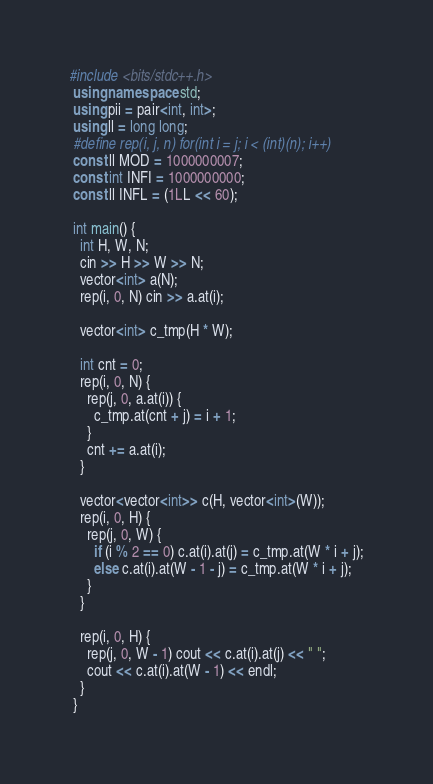<code> <loc_0><loc_0><loc_500><loc_500><_C++_>#include <bits/stdc++.h>
 using namespace std;
 using pii = pair<int, int>;
 using ll = long long;
 #define rep(i, j, n) for(int i = j; i < (int)(n); i++)
 const ll MOD = 1000000007;
 const int INFI = 1000000000;
 const ll INFL = (1LL << 60);

 int main() {
   int H, W, N;
   cin >> H >> W >> N;
   vector<int> a(N);
   rep(i, 0, N) cin >> a.at(i);

   vector<int> c_tmp(H * W);

   int cnt = 0;
   rep(i, 0, N) {
     rep(j, 0, a.at(i)) {
       c_tmp.at(cnt + j) = i + 1;
     }
     cnt += a.at(i);
   }

   vector<vector<int>> c(H, vector<int>(W));
   rep(i, 0, H) {
     rep(j, 0, W) {
       if (i % 2 == 0) c.at(i).at(j) = c_tmp.at(W * i + j);
       else c.at(i).at(W - 1 - j) = c_tmp.at(W * i + j);
     }
   }

   rep(i, 0, H) {
     rep(j, 0, W - 1) cout << c.at(i).at(j) << " ";
     cout << c.at(i).at(W - 1) << endl;
   }
 }
</code> 